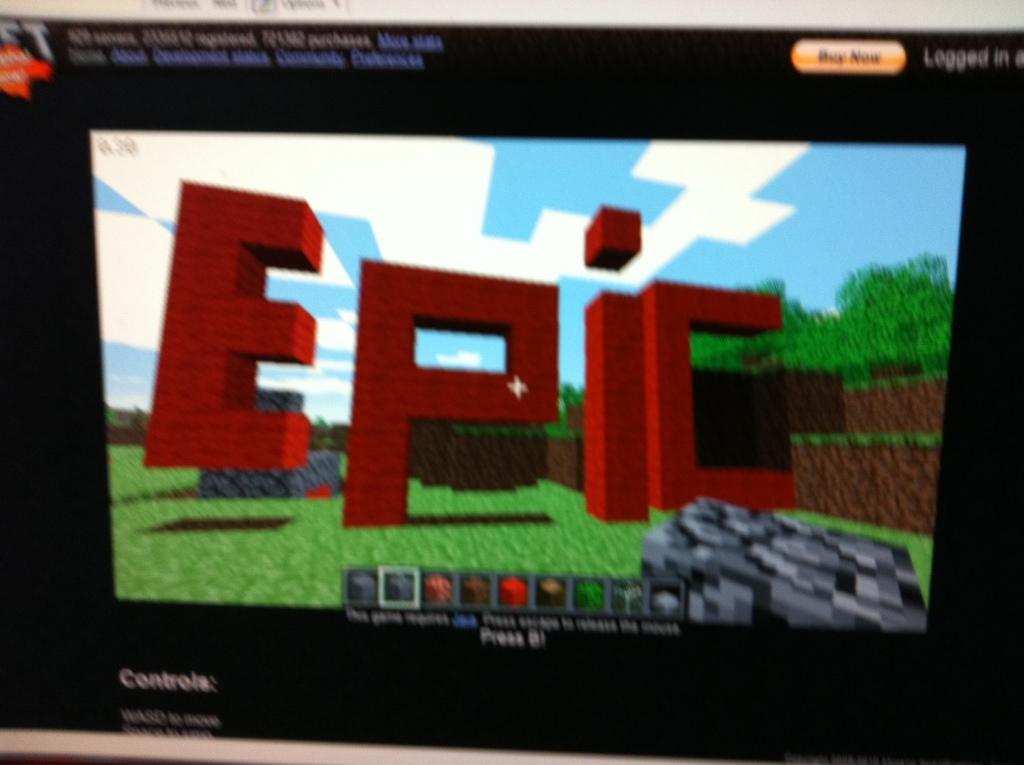How would you summarize this image in a sentence or two? In this image I can see it looks like a video game. 